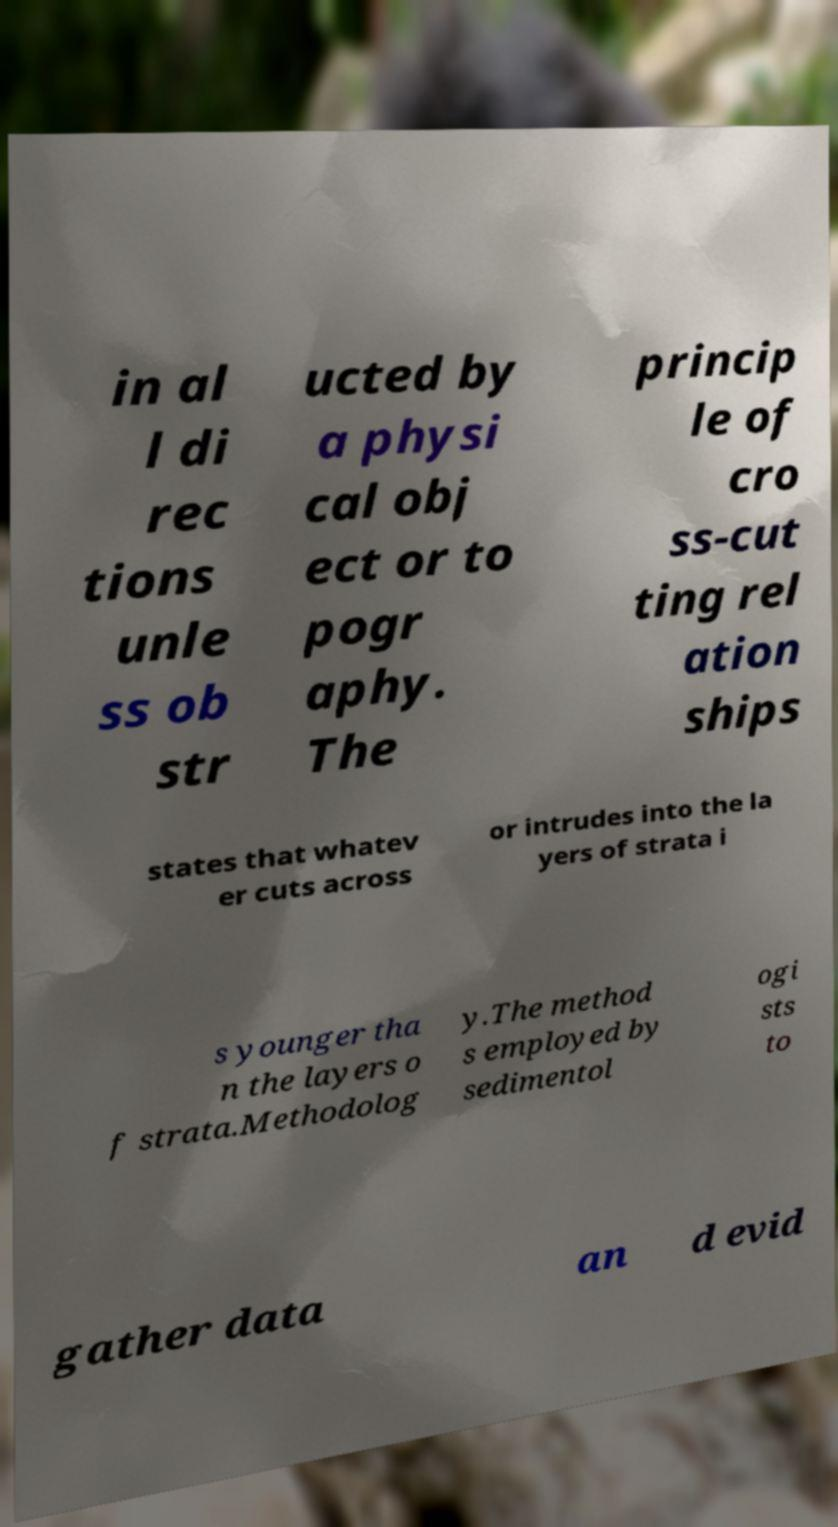Can you read and provide the text displayed in the image?This photo seems to have some interesting text. Can you extract and type it out for me? in al l di rec tions unle ss ob str ucted by a physi cal obj ect or to pogr aphy. The princip le of cro ss-cut ting rel ation ships states that whatev er cuts across or intrudes into the la yers of strata i s younger tha n the layers o f strata.Methodolog y.The method s employed by sedimentol ogi sts to gather data an d evid 